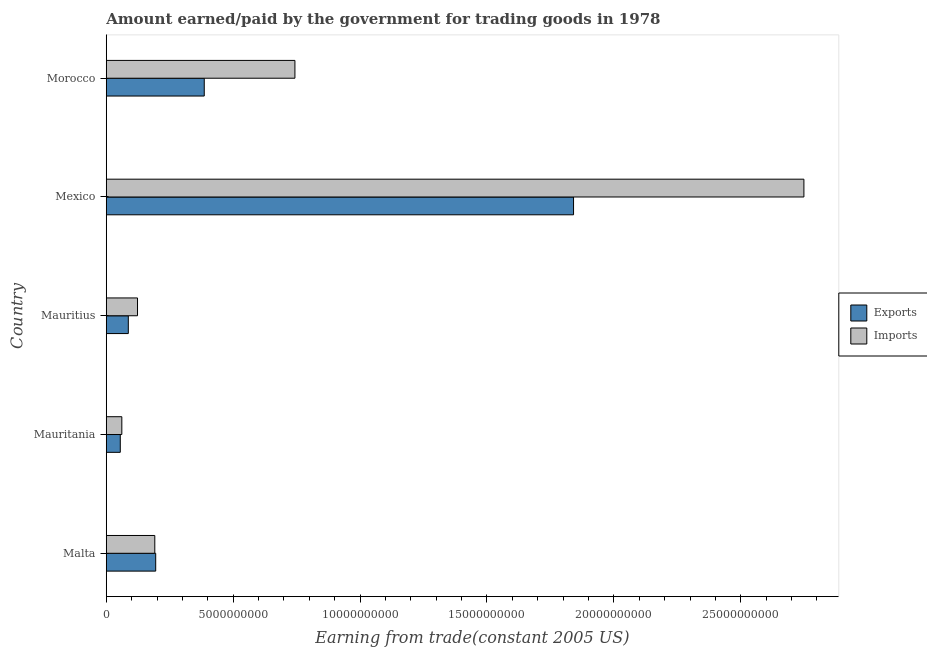Are the number of bars per tick equal to the number of legend labels?
Offer a very short reply. Yes. Are the number of bars on each tick of the Y-axis equal?
Provide a short and direct response. Yes. What is the label of the 4th group of bars from the top?
Provide a short and direct response. Mauritania. What is the amount earned from exports in Mexico?
Offer a very short reply. 1.84e+1. Across all countries, what is the maximum amount earned from exports?
Make the answer very short. 1.84e+1. Across all countries, what is the minimum amount earned from exports?
Provide a short and direct response. 5.53e+08. In which country was the amount paid for imports maximum?
Keep it short and to the point. Mexico. In which country was the amount paid for imports minimum?
Give a very brief answer. Mauritania. What is the total amount paid for imports in the graph?
Provide a succinct answer. 3.87e+1. What is the difference between the amount earned from exports in Malta and that in Morocco?
Offer a very short reply. -1.91e+09. What is the difference between the amount earned from exports in Malta and the amount paid for imports in Morocco?
Your response must be concise. -5.49e+09. What is the average amount paid for imports per country?
Provide a short and direct response. 7.74e+09. What is the difference between the amount earned from exports and amount paid for imports in Mauritius?
Provide a short and direct response. -3.63e+08. What is the ratio of the amount earned from exports in Mauritius to that in Mexico?
Make the answer very short. 0.05. Is the difference between the amount earned from exports in Malta and Mauritania greater than the difference between the amount paid for imports in Malta and Mauritania?
Make the answer very short. Yes. What is the difference between the highest and the second highest amount earned from exports?
Make the answer very short. 1.46e+1. What is the difference between the highest and the lowest amount paid for imports?
Your answer should be compact. 2.69e+1. Is the sum of the amount paid for imports in Mauritania and Mexico greater than the maximum amount earned from exports across all countries?
Ensure brevity in your answer.  Yes. What does the 1st bar from the top in Mauritius represents?
Ensure brevity in your answer.  Imports. What does the 2nd bar from the bottom in Morocco represents?
Provide a succinct answer. Imports. Are all the bars in the graph horizontal?
Your response must be concise. Yes. How many countries are there in the graph?
Your response must be concise. 5. Are the values on the major ticks of X-axis written in scientific E-notation?
Your answer should be compact. No. Does the graph contain any zero values?
Ensure brevity in your answer.  No. Does the graph contain grids?
Offer a very short reply. No. Where does the legend appear in the graph?
Keep it short and to the point. Center right. How are the legend labels stacked?
Keep it short and to the point. Vertical. What is the title of the graph?
Offer a terse response. Amount earned/paid by the government for trading goods in 1978. Does "Nitrous oxide" appear as one of the legend labels in the graph?
Keep it short and to the point. No. What is the label or title of the X-axis?
Provide a succinct answer. Earning from trade(constant 2005 US). What is the label or title of the Y-axis?
Offer a terse response. Country. What is the Earning from trade(constant 2005 US) in Exports in Malta?
Offer a terse response. 1.95e+09. What is the Earning from trade(constant 2005 US) of Imports in Malta?
Provide a succinct answer. 1.91e+09. What is the Earning from trade(constant 2005 US) of Exports in Mauritania?
Offer a terse response. 5.53e+08. What is the Earning from trade(constant 2005 US) of Imports in Mauritania?
Make the answer very short. 6.14e+08. What is the Earning from trade(constant 2005 US) in Exports in Mauritius?
Keep it short and to the point. 8.69e+08. What is the Earning from trade(constant 2005 US) in Imports in Mauritius?
Offer a terse response. 1.23e+09. What is the Earning from trade(constant 2005 US) in Exports in Mexico?
Provide a short and direct response. 1.84e+1. What is the Earning from trade(constant 2005 US) of Imports in Mexico?
Your answer should be very brief. 2.75e+1. What is the Earning from trade(constant 2005 US) in Exports in Morocco?
Offer a terse response. 3.86e+09. What is the Earning from trade(constant 2005 US) in Imports in Morocco?
Your answer should be compact. 7.43e+09. Across all countries, what is the maximum Earning from trade(constant 2005 US) of Exports?
Keep it short and to the point. 1.84e+1. Across all countries, what is the maximum Earning from trade(constant 2005 US) of Imports?
Give a very brief answer. 2.75e+1. Across all countries, what is the minimum Earning from trade(constant 2005 US) of Exports?
Provide a succinct answer. 5.53e+08. Across all countries, what is the minimum Earning from trade(constant 2005 US) of Imports?
Offer a terse response. 6.14e+08. What is the total Earning from trade(constant 2005 US) in Exports in the graph?
Offer a terse response. 2.56e+1. What is the total Earning from trade(constant 2005 US) in Imports in the graph?
Your answer should be very brief. 3.87e+1. What is the difference between the Earning from trade(constant 2005 US) in Exports in Malta and that in Mauritania?
Keep it short and to the point. 1.40e+09. What is the difference between the Earning from trade(constant 2005 US) of Imports in Malta and that in Mauritania?
Your response must be concise. 1.30e+09. What is the difference between the Earning from trade(constant 2005 US) in Exports in Malta and that in Mauritius?
Your answer should be compact. 1.08e+09. What is the difference between the Earning from trade(constant 2005 US) in Imports in Malta and that in Mauritius?
Provide a succinct answer. 6.81e+08. What is the difference between the Earning from trade(constant 2005 US) in Exports in Malta and that in Mexico?
Make the answer very short. -1.65e+1. What is the difference between the Earning from trade(constant 2005 US) of Imports in Malta and that in Mexico?
Your response must be concise. -2.56e+1. What is the difference between the Earning from trade(constant 2005 US) in Exports in Malta and that in Morocco?
Provide a short and direct response. -1.91e+09. What is the difference between the Earning from trade(constant 2005 US) of Imports in Malta and that in Morocco?
Provide a short and direct response. -5.52e+09. What is the difference between the Earning from trade(constant 2005 US) of Exports in Mauritania and that in Mauritius?
Offer a very short reply. -3.16e+08. What is the difference between the Earning from trade(constant 2005 US) of Imports in Mauritania and that in Mauritius?
Make the answer very short. -6.18e+08. What is the difference between the Earning from trade(constant 2005 US) of Exports in Mauritania and that in Mexico?
Offer a very short reply. -1.79e+1. What is the difference between the Earning from trade(constant 2005 US) in Imports in Mauritania and that in Mexico?
Give a very brief answer. -2.69e+1. What is the difference between the Earning from trade(constant 2005 US) in Exports in Mauritania and that in Morocco?
Your response must be concise. -3.31e+09. What is the difference between the Earning from trade(constant 2005 US) in Imports in Mauritania and that in Morocco?
Make the answer very short. -6.82e+09. What is the difference between the Earning from trade(constant 2005 US) in Exports in Mauritius and that in Mexico?
Your answer should be compact. -1.75e+1. What is the difference between the Earning from trade(constant 2005 US) in Imports in Mauritius and that in Mexico?
Make the answer very short. -2.63e+1. What is the difference between the Earning from trade(constant 2005 US) of Exports in Mauritius and that in Morocco?
Give a very brief answer. -2.99e+09. What is the difference between the Earning from trade(constant 2005 US) in Imports in Mauritius and that in Morocco?
Your answer should be compact. -6.20e+09. What is the difference between the Earning from trade(constant 2005 US) in Exports in Mexico and that in Morocco?
Your answer should be compact. 1.46e+1. What is the difference between the Earning from trade(constant 2005 US) in Imports in Mexico and that in Morocco?
Offer a very short reply. 2.01e+1. What is the difference between the Earning from trade(constant 2005 US) in Exports in Malta and the Earning from trade(constant 2005 US) in Imports in Mauritania?
Provide a succinct answer. 1.33e+09. What is the difference between the Earning from trade(constant 2005 US) of Exports in Malta and the Earning from trade(constant 2005 US) of Imports in Mauritius?
Offer a very short reply. 7.16e+08. What is the difference between the Earning from trade(constant 2005 US) of Exports in Malta and the Earning from trade(constant 2005 US) of Imports in Mexico?
Provide a succinct answer. -2.55e+1. What is the difference between the Earning from trade(constant 2005 US) in Exports in Malta and the Earning from trade(constant 2005 US) in Imports in Morocco?
Provide a short and direct response. -5.49e+09. What is the difference between the Earning from trade(constant 2005 US) of Exports in Mauritania and the Earning from trade(constant 2005 US) of Imports in Mauritius?
Your answer should be compact. -6.79e+08. What is the difference between the Earning from trade(constant 2005 US) in Exports in Mauritania and the Earning from trade(constant 2005 US) in Imports in Mexico?
Ensure brevity in your answer.  -2.69e+1. What is the difference between the Earning from trade(constant 2005 US) of Exports in Mauritania and the Earning from trade(constant 2005 US) of Imports in Morocco?
Your response must be concise. -6.88e+09. What is the difference between the Earning from trade(constant 2005 US) of Exports in Mauritius and the Earning from trade(constant 2005 US) of Imports in Mexico?
Provide a succinct answer. -2.66e+1. What is the difference between the Earning from trade(constant 2005 US) in Exports in Mauritius and the Earning from trade(constant 2005 US) in Imports in Morocco?
Your answer should be very brief. -6.56e+09. What is the difference between the Earning from trade(constant 2005 US) in Exports in Mexico and the Earning from trade(constant 2005 US) in Imports in Morocco?
Give a very brief answer. 1.10e+1. What is the average Earning from trade(constant 2005 US) of Exports per country?
Your answer should be compact. 5.13e+09. What is the average Earning from trade(constant 2005 US) in Imports per country?
Keep it short and to the point. 7.74e+09. What is the difference between the Earning from trade(constant 2005 US) in Exports and Earning from trade(constant 2005 US) in Imports in Malta?
Provide a succinct answer. 3.54e+07. What is the difference between the Earning from trade(constant 2005 US) in Exports and Earning from trade(constant 2005 US) in Imports in Mauritania?
Your answer should be very brief. -6.08e+07. What is the difference between the Earning from trade(constant 2005 US) of Exports and Earning from trade(constant 2005 US) of Imports in Mauritius?
Provide a succinct answer. -3.63e+08. What is the difference between the Earning from trade(constant 2005 US) of Exports and Earning from trade(constant 2005 US) of Imports in Mexico?
Provide a succinct answer. -9.08e+09. What is the difference between the Earning from trade(constant 2005 US) in Exports and Earning from trade(constant 2005 US) in Imports in Morocco?
Provide a succinct answer. -3.57e+09. What is the ratio of the Earning from trade(constant 2005 US) of Exports in Malta to that in Mauritania?
Offer a very short reply. 3.52. What is the ratio of the Earning from trade(constant 2005 US) in Imports in Malta to that in Mauritania?
Give a very brief answer. 3.12. What is the ratio of the Earning from trade(constant 2005 US) of Exports in Malta to that in Mauritius?
Your response must be concise. 2.24. What is the ratio of the Earning from trade(constant 2005 US) of Imports in Malta to that in Mauritius?
Your answer should be very brief. 1.55. What is the ratio of the Earning from trade(constant 2005 US) of Exports in Malta to that in Mexico?
Give a very brief answer. 0.11. What is the ratio of the Earning from trade(constant 2005 US) of Imports in Malta to that in Mexico?
Give a very brief answer. 0.07. What is the ratio of the Earning from trade(constant 2005 US) of Exports in Malta to that in Morocco?
Offer a very short reply. 0.5. What is the ratio of the Earning from trade(constant 2005 US) in Imports in Malta to that in Morocco?
Give a very brief answer. 0.26. What is the ratio of the Earning from trade(constant 2005 US) in Exports in Mauritania to that in Mauritius?
Provide a succinct answer. 0.64. What is the ratio of the Earning from trade(constant 2005 US) of Imports in Mauritania to that in Mauritius?
Offer a very short reply. 0.5. What is the ratio of the Earning from trade(constant 2005 US) of Exports in Mauritania to that in Mexico?
Offer a very short reply. 0.03. What is the ratio of the Earning from trade(constant 2005 US) in Imports in Mauritania to that in Mexico?
Your answer should be compact. 0.02. What is the ratio of the Earning from trade(constant 2005 US) in Exports in Mauritania to that in Morocco?
Your response must be concise. 0.14. What is the ratio of the Earning from trade(constant 2005 US) of Imports in Mauritania to that in Morocco?
Ensure brevity in your answer.  0.08. What is the ratio of the Earning from trade(constant 2005 US) in Exports in Mauritius to that in Mexico?
Ensure brevity in your answer.  0.05. What is the ratio of the Earning from trade(constant 2005 US) of Imports in Mauritius to that in Mexico?
Give a very brief answer. 0.04. What is the ratio of the Earning from trade(constant 2005 US) in Exports in Mauritius to that in Morocco?
Offer a terse response. 0.23. What is the ratio of the Earning from trade(constant 2005 US) in Imports in Mauritius to that in Morocco?
Make the answer very short. 0.17. What is the ratio of the Earning from trade(constant 2005 US) of Exports in Mexico to that in Morocco?
Offer a terse response. 4.77. What is the ratio of the Earning from trade(constant 2005 US) of Imports in Mexico to that in Morocco?
Ensure brevity in your answer.  3.7. What is the difference between the highest and the second highest Earning from trade(constant 2005 US) of Exports?
Ensure brevity in your answer.  1.46e+1. What is the difference between the highest and the second highest Earning from trade(constant 2005 US) in Imports?
Offer a terse response. 2.01e+1. What is the difference between the highest and the lowest Earning from trade(constant 2005 US) in Exports?
Make the answer very short. 1.79e+1. What is the difference between the highest and the lowest Earning from trade(constant 2005 US) of Imports?
Provide a succinct answer. 2.69e+1. 